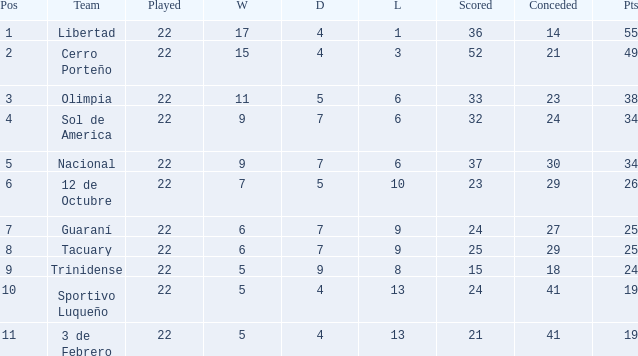Give me the full table as a dictionary. {'header': ['Pos', 'Team', 'Played', 'W', 'D', 'L', 'Scored', 'Conceded', 'Pts'], 'rows': [['1', 'Libertad', '22', '17', '4', '1', '36', '14', '55'], ['2', 'Cerro Porteño', '22', '15', '4', '3', '52', '21', '49'], ['3', 'Olimpia', '22', '11', '5', '6', '33', '23', '38'], ['4', 'Sol de America', '22', '9', '7', '6', '32', '24', '34'], ['5', 'Nacional', '22', '9', '7', '6', '37', '30', '34'], ['6', '12 de Octubre', '22', '7', '5', '10', '23', '29', '26'], ['7', 'Guaraní', '22', '6', '7', '9', '24', '27', '25'], ['8', 'Tacuary', '22', '6', '7', '9', '25', '29', '25'], ['9', 'Trinidense', '22', '5', '9', '8', '15', '18', '24'], ['10', 'Sportivo Luqueño', '22', '5', '4', '13', '24', '41', '19'], ['11', '3 de Febrero', '22', '5', '4', '13', '21', '41', '19']]} What is the value scored when there were 19 points for the team 3 de Febrero? 21.0. 